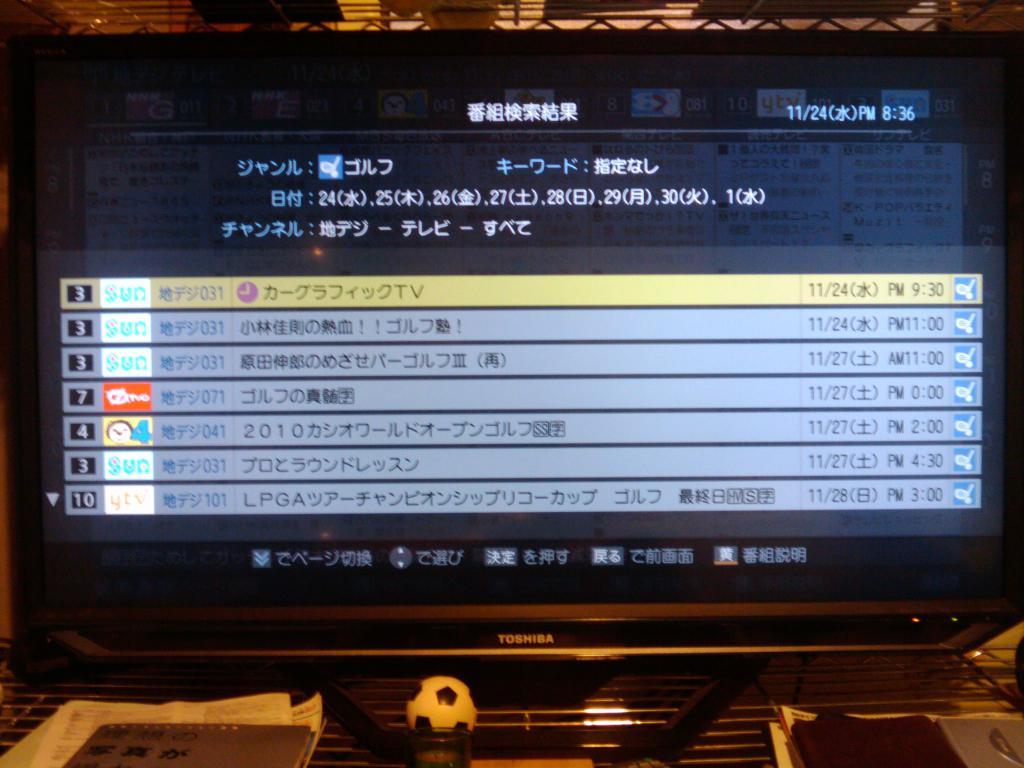What brand is the tv?
Offer a very short reply. Toshiba. What time is displayed on the screen?
Make the answer very short. 8:36. 